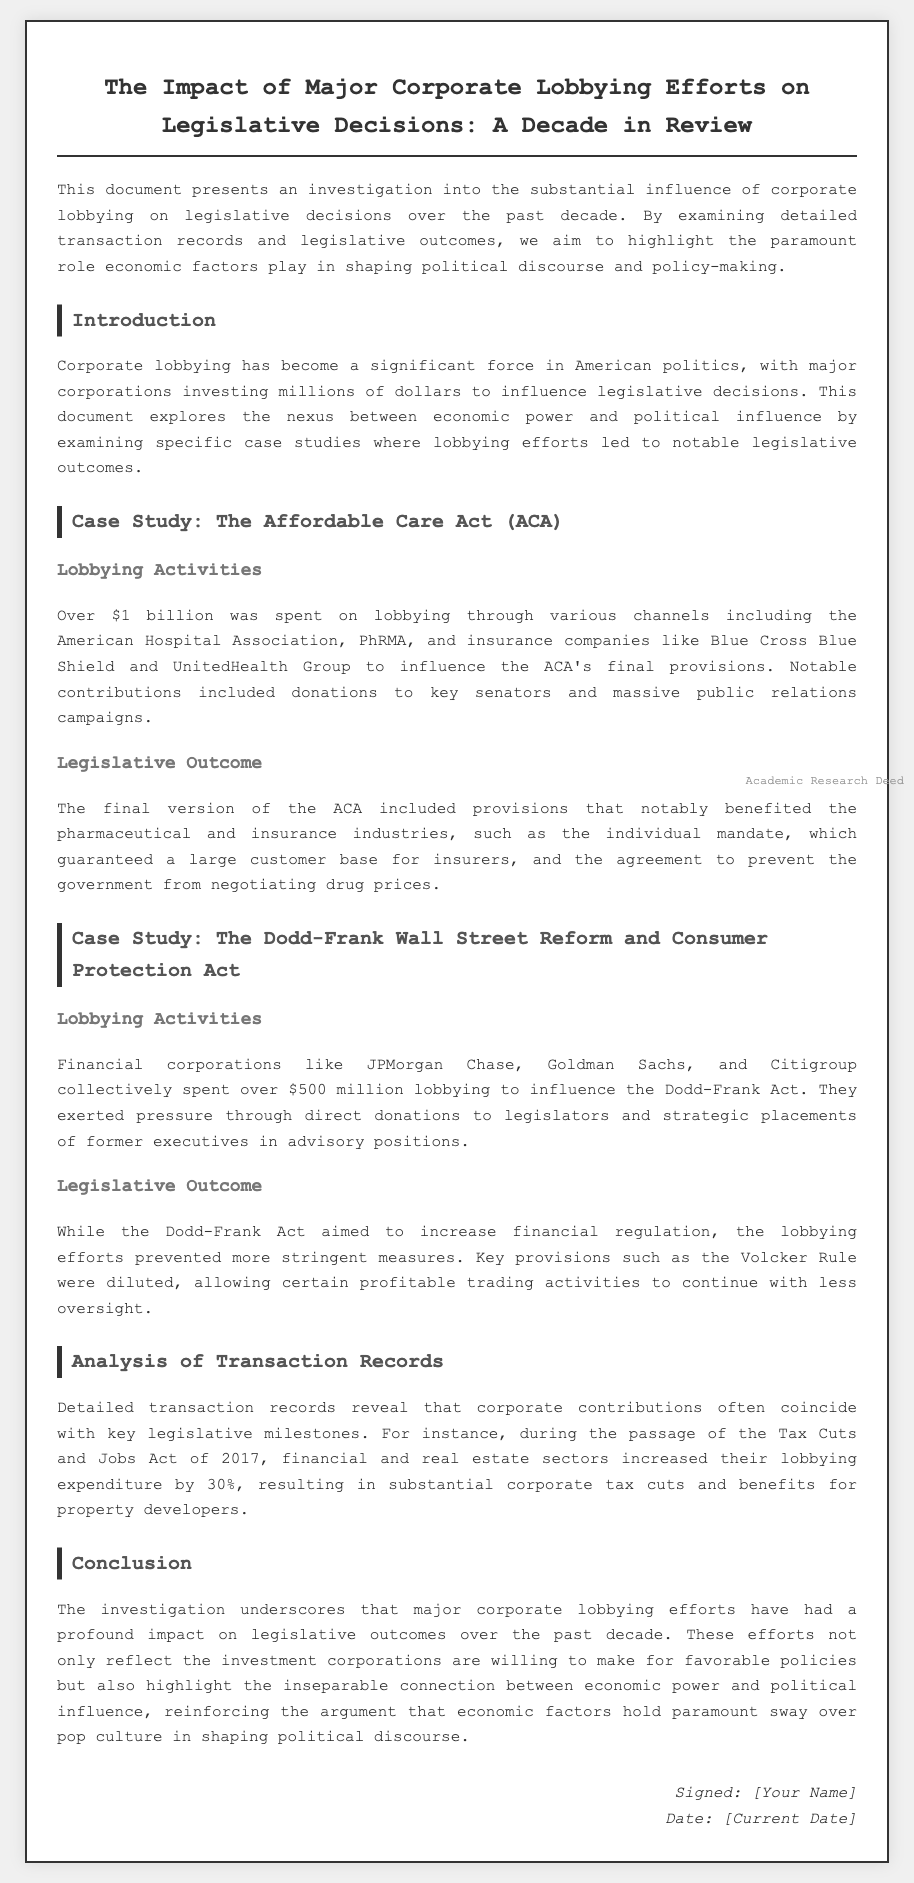What was the total amount spent on lobbying for the Affordable Care Act? The document states that over $1 billion was spent on lobbying for the Affordable Care Act.
Answer: Over $1 billion Which industries benefitted from the final provisions of the Affordable Care Act? The final provisions of the ACA benefited the pharmaceutical and insurance industries.
Answer: Pharmaceutical and insurance How much did financial corporations spend on lobbying for the Dodd-Frank Act? It is noted that financial corporations like JPMorgan Chase, Goldman Sachs, and Citigroup spent over $500 million on lobbying.
Answer: Over $500 million What impact did lobbying efforts have on the Volcker Rule? The lobbying efforts led to the dilution of the Volcker Rule, allowing certain trading activities to continue with less oversight.
Answer: Dilution of the Volcker Rule What percentage increase in lobbying expenditure occurred during the passage of the Tax Cuts and Jobs Act of 2017? It is mentioned that the financial and real estate sectors increased their lobbying expenditure by 30%.
Answer: 30% What does this investigation underscore about corporate lobbying? The investigation underscores the profound impact of major corporate lobbying efforts on legislative outcomes.
Answer: Profound impact What critical connection is reinforced by the document regarding economic power? The document reinforces the connection that economic power and political influence are inseparable.
Answer: Economic power and political influence are inseparable Who signed the document? The signature section indicates that the document was signed by [Your Name].
Answer: [Your Name] What type of document is this? The document is categorized as an "Academic Research Deed."
Answer: Academic Research Deed 